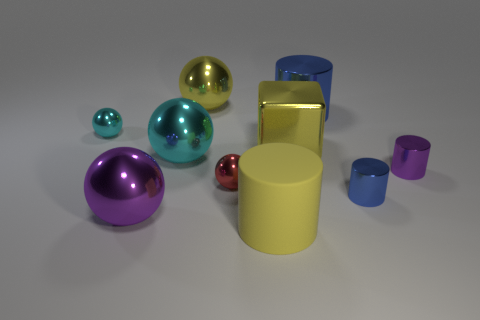Is there any other thing that is the same material as the big yellow cylinder?
Your answer should be very brief. No. How many cyan balls are the same size as the red object?
Provide a succinct answer. 1. What number of objects are yellow objects in front of the large purple metallic thing or metallic things left of the yellow block?
Your response must be concise. 6. Is the purple thing on the right side of the yellow metal sphere made of the same material as the big object that is in front of the purple ball?
Offer a terse response. No. There is a big yellow rubber object that is to the left of the tiny metal cylinder in front of the small red metal ball; what is its shape?
Ensure brevity in your answer.  Cylinder. Are there any other things that are the same color as the matte object?
Ensure brevity in your answer.  Yes. There is a cylinder behind the small thing to the right of the small blue thing; is there a matte cylinder behind it?
Your answer should be compact. No. There is a big cylinder that is behind the yellow cylinder; is it the same color as the large ball that is behind the tiny cyan metallic ball?
Provide a short and direct response. No. There is a cube that is the same size as the purple metal ball; what material is it?
Ensure brevity in your answer.  Metal. What is the size of the yellow metallic object that is in front of the cylinder that is behind the tiny metal object to the left of the big cyan shiny ball?
Make the answer very short. Large. 